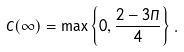<formula> <loc_0><loc_0><loc_500><loc_500>C ( \infty ) = \max \left \{ 0 , \frac { 2 - 3 \Pi } { 4 } \right \} .</formula> 